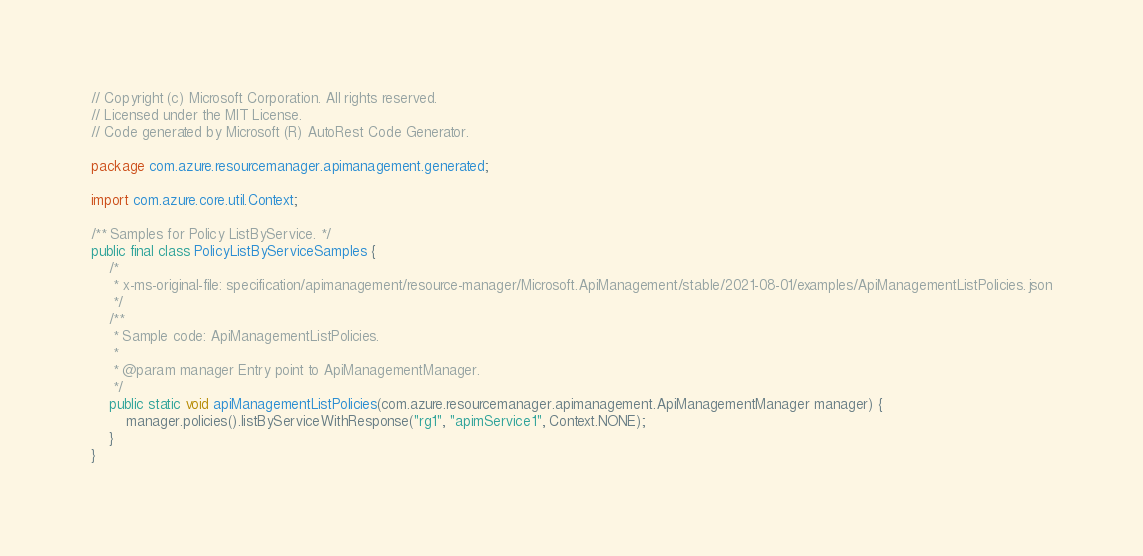Convert code to text. <code><loc_0><loc_0><loc_500><loc_500><_Java_>// Copyright (c) Microsoft Corporation. All rights reserved.
// Licensed under the MIT License.
// Code generated by Microsoft (R) AutoRest Code Generator.

package com.azure.resourcemanager.apimanagement.generated;

import com.azure.core.util.Context;

/** Samples for Policy ListByService. */
public final class PolicyListByServiceSamples {
    /*
     * x-ms-original-file: specification/apimanagement/resource-manager/Microsoft.ApiManagement/stable/2021-08-01/examples/ApiManagementListPolicies.json
     */
    /**
     * Sample code: ApiManagementListPolicies.
     *
     * @param manager Entry point to ApiManagementManager.
     */
    public static void apiManagementListPolicies(com.azure.resourcemanager.apimanagement.ApiManagementManager manager) {
        manager.policies().listByServiceWithResponse("rg1", "apimService1", Context.NONE);
    }
}
</code> 